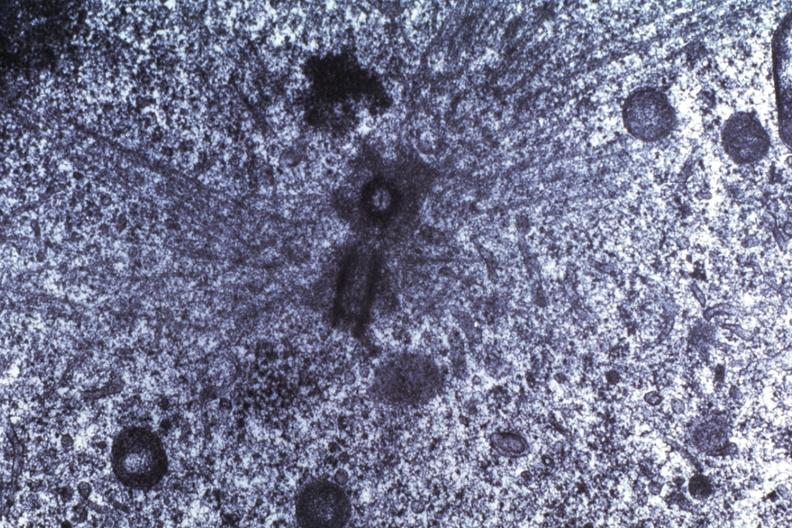what is present?
Answer the question using a single word or phrase. Brain 